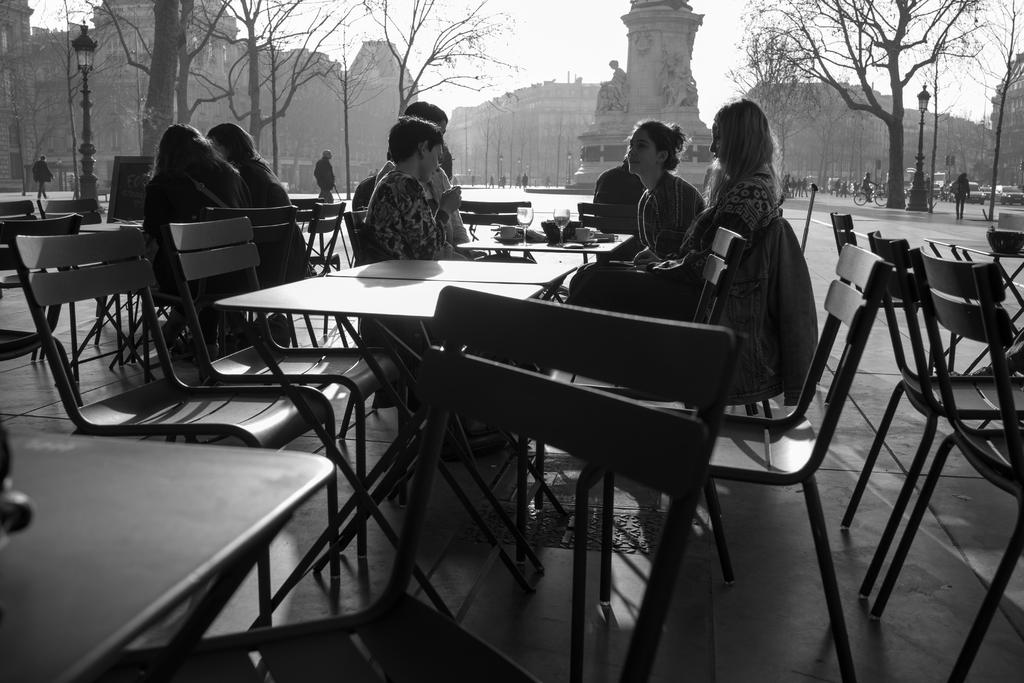What are the people in the image doing? The people in the image are sitting on chairs. What is between the chairs? There are tables between the chairs. What can be seen in the background of the image? There are trees and buildings in the vicinity. What type of hammer is being used by the person in the image? There is no hammer present in the image; the people are sitting on chairs and there are tables between them. 